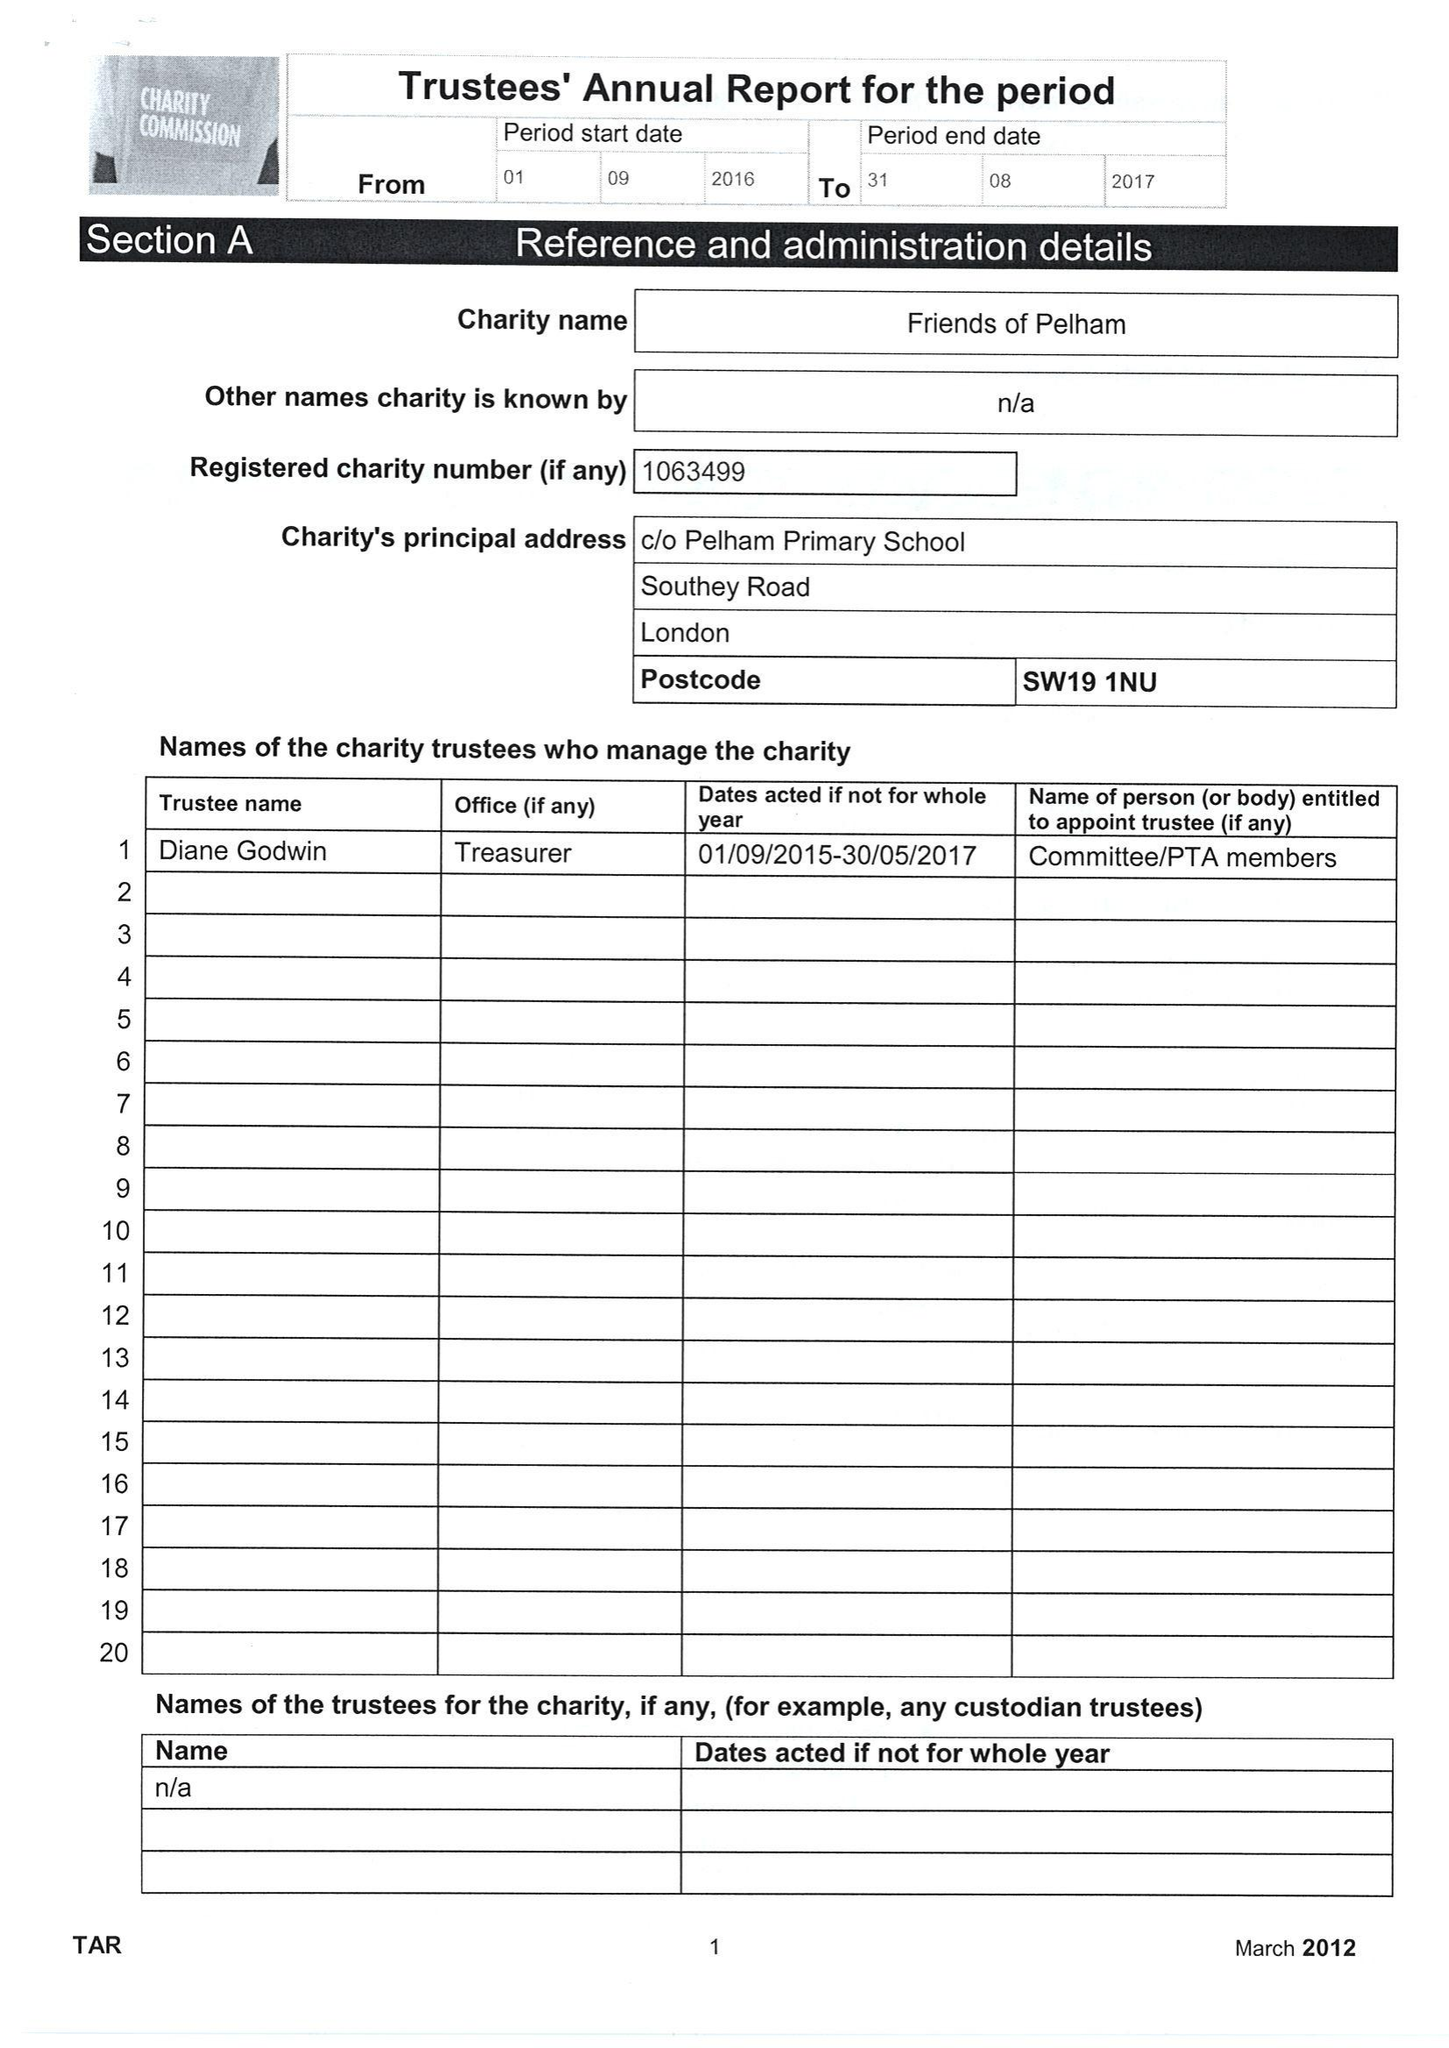What is the value for the income_annually_in_british_pounds?
Answer the question using a single word or phrase. 38974.00 